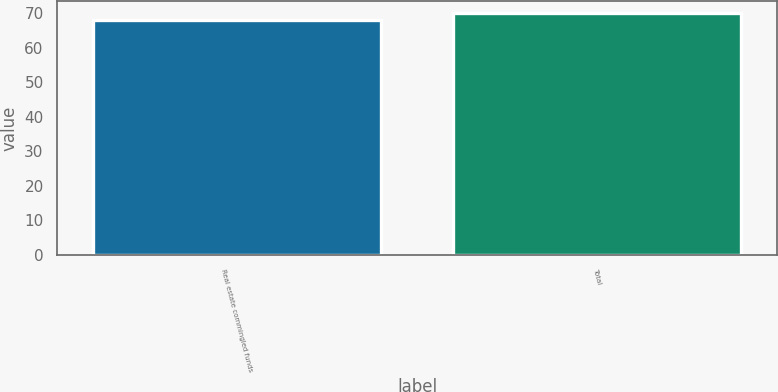Convert chart to OTSL. <chart><loc_0><loc_0><loc_500><loc_500><bar_chart><fcel>Real estate commingled funds<fcel>Total<nl><fcel>68<fcel>70<nl></chart> 